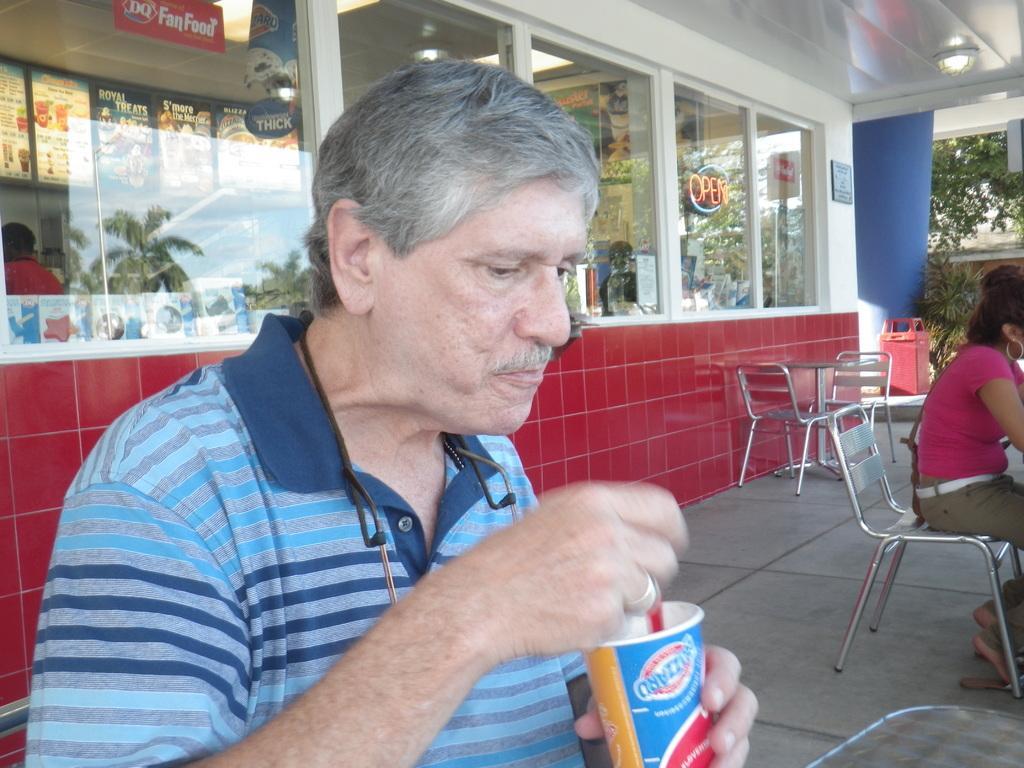Describe this image in one or two sentences. In this image I can see few people are sitting on chairs. Here I can see he is holding a cup. In the background I can see few more chairs, a tree and a building. 